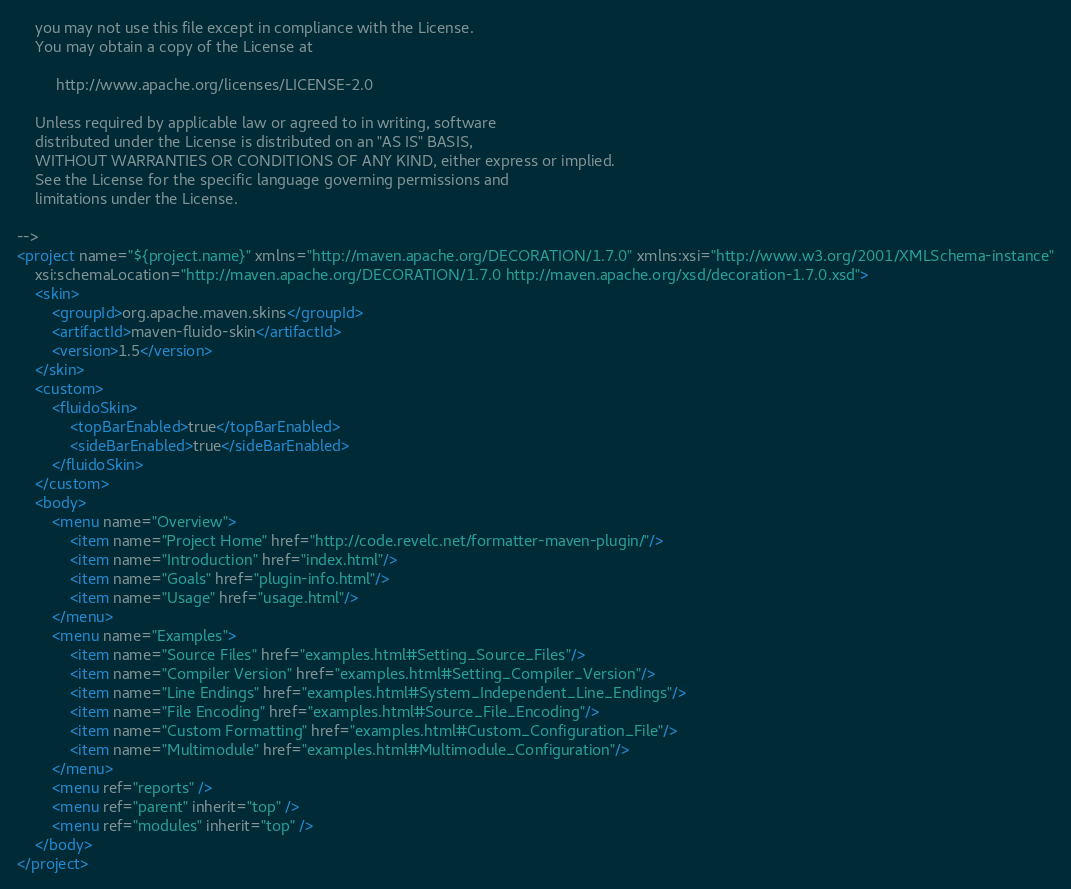<code> <loc_0><loc_0><loc_500><loc_500><_XML_>    you may not use this file except in compliance with the License.
    You may obtain a copy of the License at

         http://www.apache.org/licenses/LICENSE-2.0

    Unless required by applicable law or agreed to in writing, software
    distributed under the License is distributed on an "AS IS" BASIS,
    WITHOUT WARRANTIES OR CONDITIONS OF ANY KIND, either express or implied.
    See the License for the specific language governing permissions and
    limitations under the License.

-->
<project name="${project.name}" xmlns="http://maven.apache.org/DECORATION/1.7.0" xmlns:xsi="http://www.w3.org/2001/XMLSchema-instance"
    xsi:schemaLocation="http://maven.apache.org/DECORATION/1.7.0 http://maven.apache.org/xsd/decoration-1.7.0.xsd">
    <skin>
        <groupId>org.apache.maven.skins</groupId>
        <artifactId>maven-fluido-skin</artifactId>
        <version>1.5</version>
    </skin>
    <custom>
        <fluidoSkin>
            <topBarEnabled>true</topBarEnabled>
            <sideBarEnabled>true</sideBarEnabled>
        </fluidoSkin>
    </custom>
    <body>
        <menu name="Overview">
            <item name="Project Home" href="http://code.revelc.net/formatter-maven-plugin/"/>
            <item name="Introduction" href="index.html"/>
            <item name="Goals" href="plugin-info.html"/>
            <item name="Usage" href="usage.html"/>
        </menu>
        <menu name="Examples">
            <item name="Source Files" href="examples.html#Setting_Source_Files"/>
            <item name="Compiler Version" href="examples.html#Setting_Compiler_Version"/>
            <item name="Line Endings" href="examples.html#System_Independent_Line_Endings"/>
            <item name="File Encoding" href="examples.html#Source_File_Encoding"/>
            <item name="Custom Formatting" href="examples.html#Custom_Configuration_File"/>
            <item name="Multimodule" href="examples.html#Multimodule_Configuration"/>
        </menu>
        <menu ref="reports" />
        <menu ref="parent" inherit="top" />
        <menu ref="modules" inherit="top" />
    </body>
</project>
</code> 